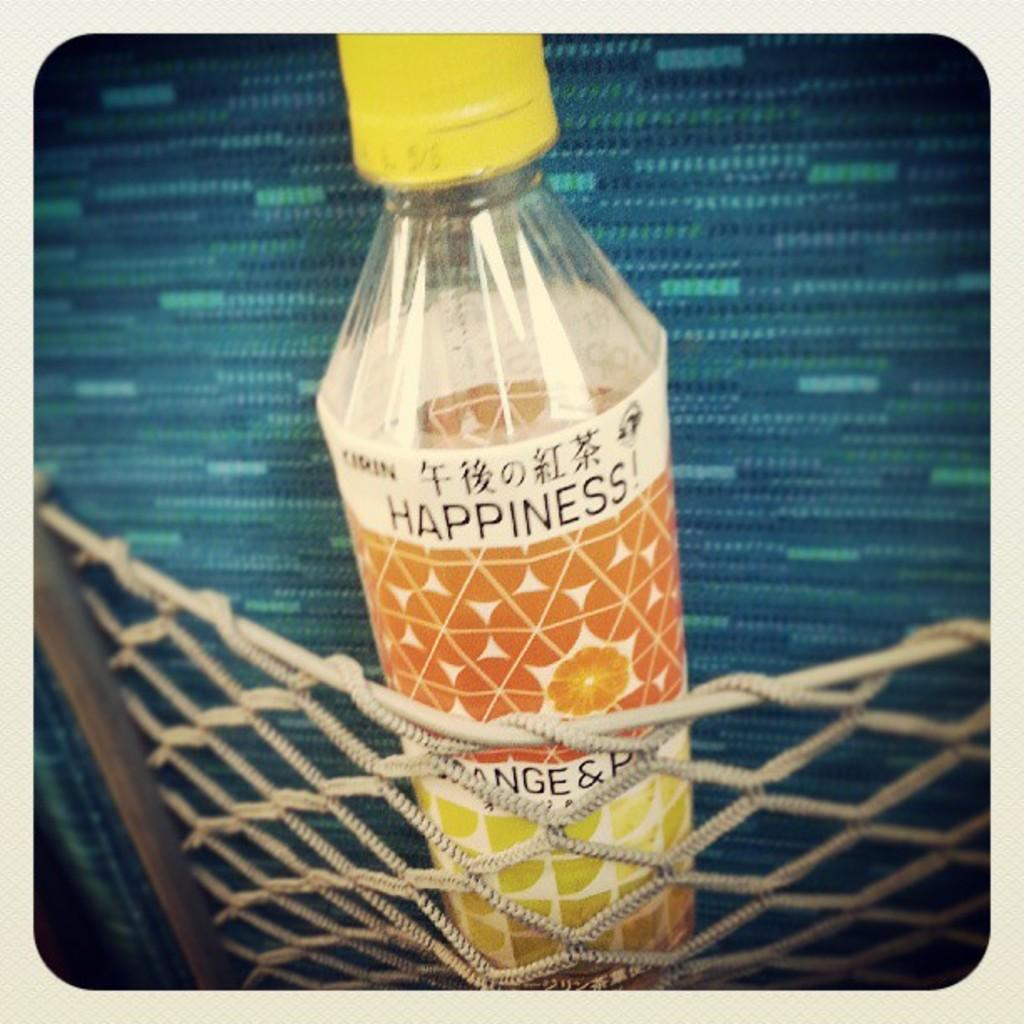<image>
Provide a brief description of the given image. A bottle of Happiness has a yellow cap and Chinese writing on it. 